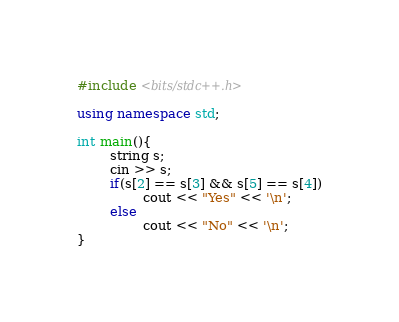Convert code to text. <code><loc_0><loc_0><loc_500><loc_500><_C++_>#include <bits/stdc++.h>

using namespace std;

int main(){
        string s;
        cin >> s;
        if(s[2] == s[3] && s[5] == s[4])
                cout << "Yes" << '\n';
        else
                cout << "No" << '\n';
}</code> 